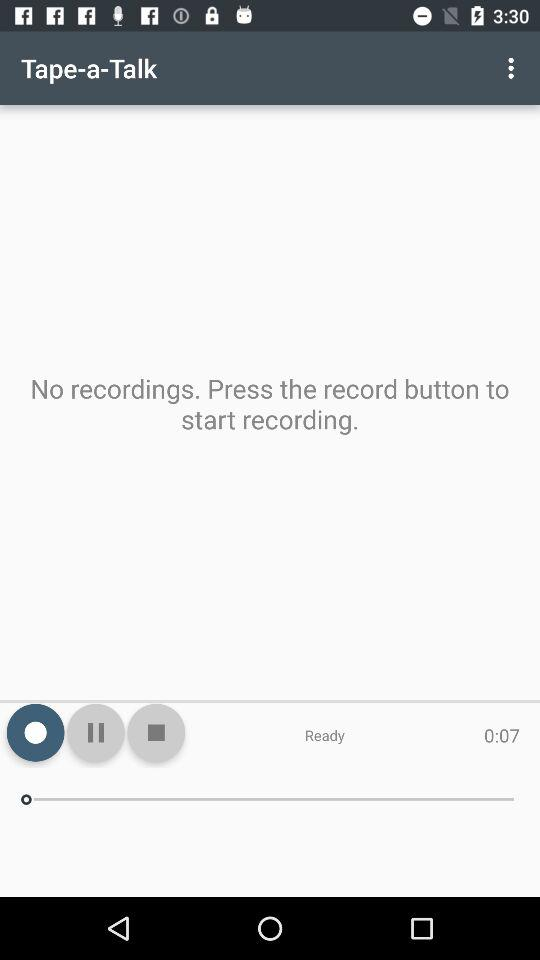What is the name of the application? The name of the application is "Tape-a-Talk". 